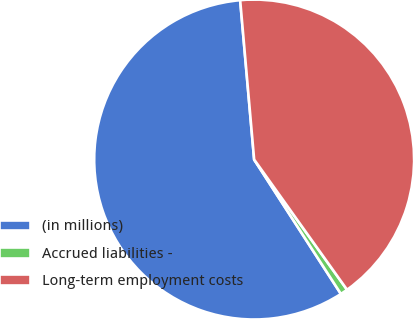Convert chart. <chart><loc_0><loc_0><loc_500><loc_500><pie_chart><fcel>(in millions)<fcel>Accrued liabilities -<fcel>Long-term employment costs<nl><fcel>57.73%<fcel>0.74%<fcel>41.53%<nl></chart> 